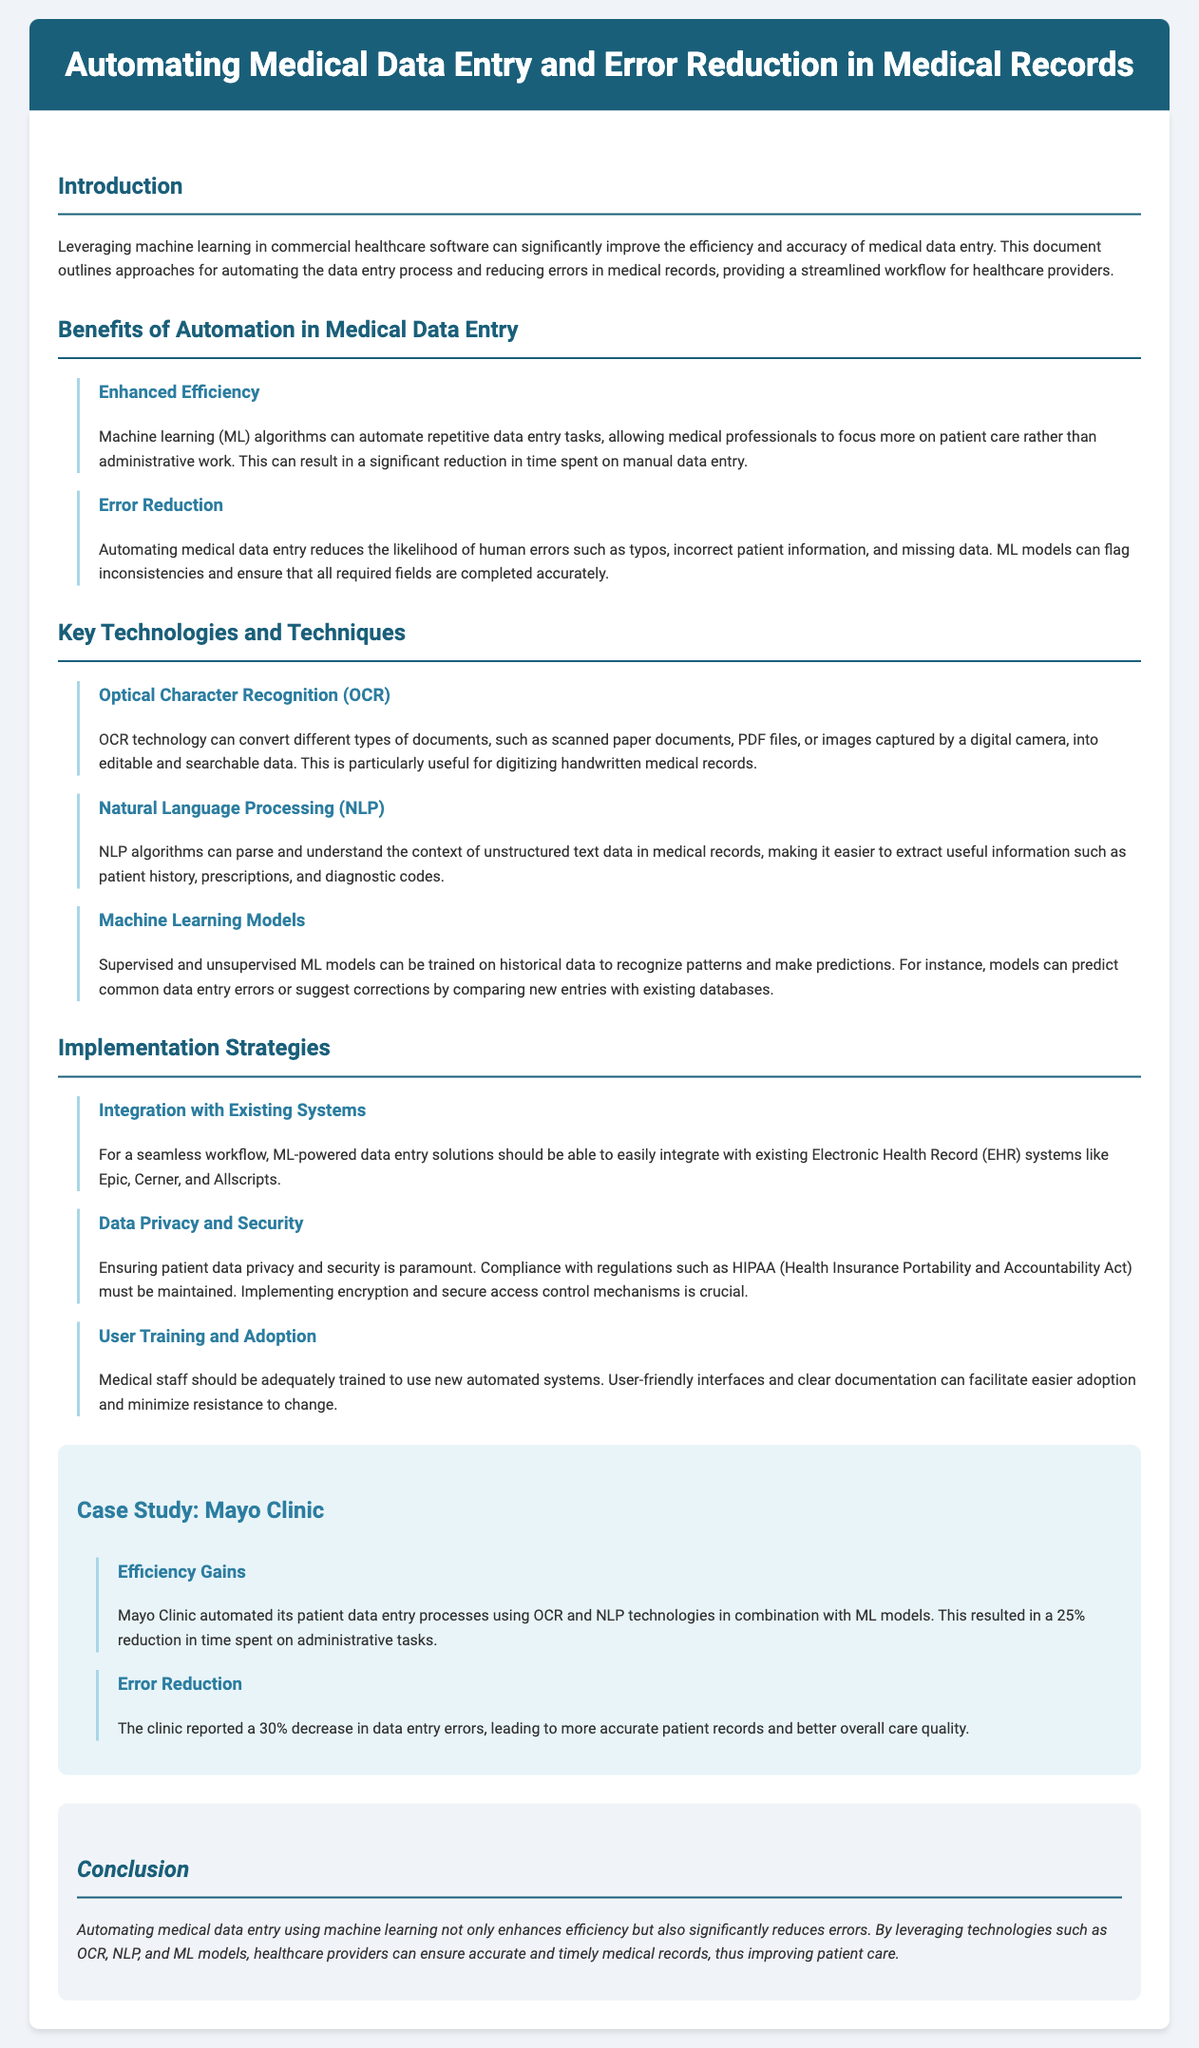What is the title of the document? The title is the main heading of the document, which is provided in the header section.
Answer: Automating Medical Data Entry and Error Reduction in Medical Records What is one key benefit of automation mentioned? This benefit is listed under the section discussing the advantages of automation, specifically referring to its impact on workflow.
Answer: Enhanced Efficiency Which technology is used to digitize handwritten medical records? This information can be found in the section on Key Technologies and Techniques, specifically under OCR technology.
Answer: Optical Character Recognition (OCR) What decrease in data entry errors did Mayo Clinic report? This statistic is included in the case study section regarding the outcomes of implementing automation at Mayo Clinic.
Answer: 30% What is crucial for ensuring patient data privacy and security? This requirement is emphasized under the implementation strategies section regarding data privacy and security.
Answer: Compliance with HIPAA Which machine learning applications are mentioned for improving data entry? This information is derived from the Key Technologies and Techniques section, which highlights machine learning.
Answer: Supervised and unsupervised ML models What is necessary for user training and adoption of automated systems? This aspect is mentioned under the user training and adoption subsection, which focuses on encouraging the medical staff to adapt to new systems.
Answer: User-friendly interfaces What percent reduction in time spent on administrative tasks did Mayo Clinic achieve? This figure is mentioned in the efficiency gains subsection of the case study.
Answer: 25% What type of document format is primarily discussed for automation? This refers to the types of documents that can benefit from automation, as indicated in the introduction and technology descriptions.
Answer: Medical records 